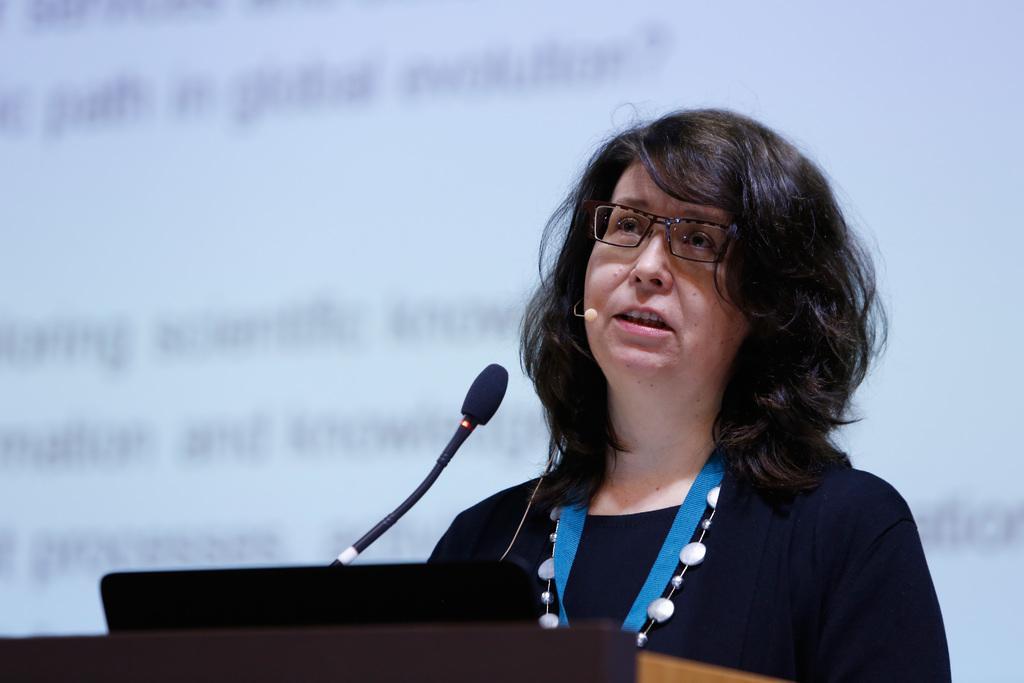Can you describe this image briefly? In this image we can see a woman wearing black dress, identity card and spectacles is standing near the podium where a mic is placed. The background of the image is slightly blurred, where we can see the projector screen on which we can see some text is displayed. 